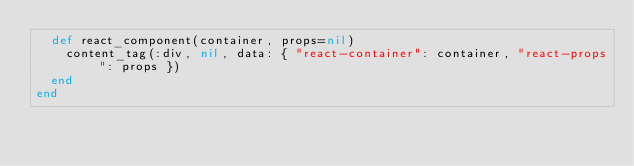Convert code to text. <code><loc_0><loc_0><loc_500><loc_500><_Ruby_>  def react_component(container, props=nil)
    content_tag(:div, nil, data: { "react-container": container, "react-props": props })
  end
end
</code> 